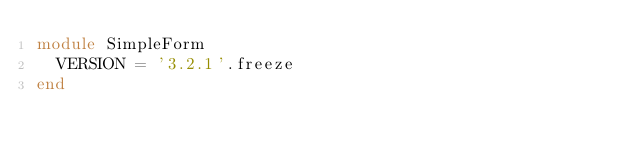Convert code to text. <code><loc_0><loc_0><loc_500><loc_500><_Ruby_>module SimpleForm
  VERSION = '3.2.1'.freeze
end
</code> 